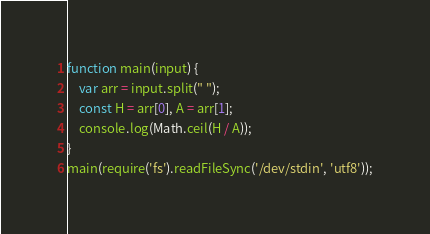<code> <loc_0><loc_0><loc_500><loc_500><_JavaScript_>function main(input) {
    var arr = input.split(" ");
    const H = arr[0], A = arr[1];
    console.log(Math.ceil(H / A));
}
main(require('fs').readFileSync('/dev/stdin', 'utf8'));</code> 